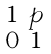<formula> <loc_0><loc_0><loc_500><loc_500>\begin{smallmatrix} 1 & p \\ 0 & 1 \end{smallmatrix}</formula> 